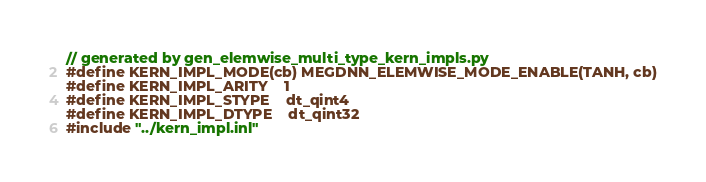<code> <loc_0><loc_0><loc_500><loc_500><_Cuda_>// generated by gen_elemwise_multi_type_kern_impls.py
#define KERN_IMPL_MODE(cb) MEGDNN_ELEMWISE_MODE_ENABLE(TANH, cb)
#define KERN_IMPL_ARITY    1
#define KERN_IMPL_STYPE    dt_qint4
#define KERN_IMPL_DTYPE    dt_qint32
#include "../kern_impl.inl"
</code> 